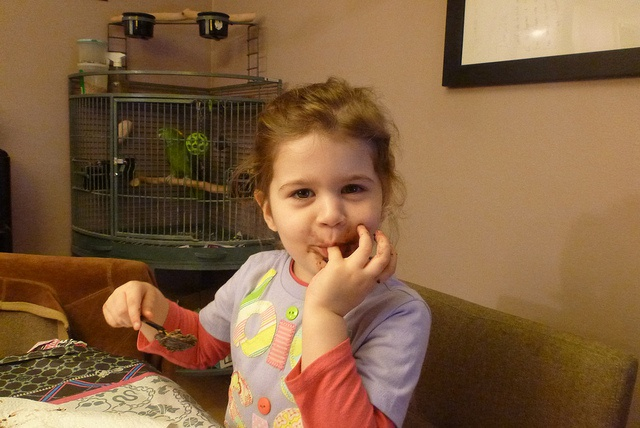Describe the objects in this image and their specific colors. I can see people in gray, tan, and maroon tones, chair in gray, maroon, black, and olive tones, dining table in gray, tan, maroon, and olive tones, chair in gray, maroon, brown, and black tones, and cake in gray, beige, and tan tones in this image. 